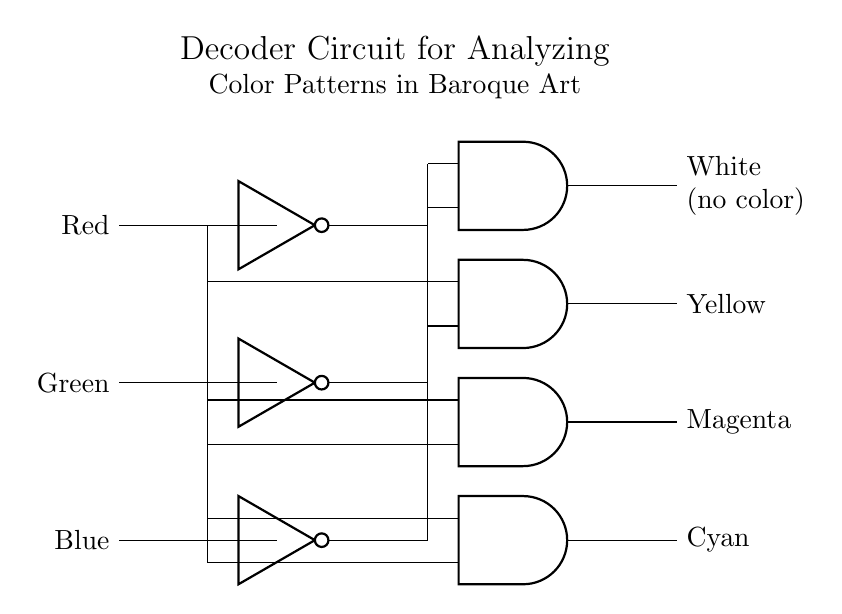What are the input colors for this decoder circuit? The circuit has three input colors labeled Red, Green, and Blue, shown at the left side of the diagram.
Answer: Red, Green, Blue What is the output color when all inputs are active? When all inputs (Red, Green, Blue) are high, the AND gates receive inputs from their respective NOT gates, leading to no signal at the output. Therefore, the output is White (no color).
Answer: White How many AND gates are present in the circuit? The circuit features four AND gates, each processing different combinations of the inputs. This is indicated by the four distinct AND gate symbols in the diagram.
Answer: Four Which output corresponds to the combination of Red and Green active, but not Blue? When Red and Green are active, but Blue is not active, the second AND gate produces Yellow as the output. This is indicated by the connections made to the second AND gate.
Answer: Yellow Describe the output color that occurs when only the Blue input is active. With only the Blue input active, the third AND gate will have both of its inputs inactive (since it requires a NOT signal from Red and Green), resulting in an output of Magenta. This is deduced from the labeling of the output from the third AND gate.
Answer: Magenta What is the function of the NOT gates in this circuit? The NOT gates invert the signals of the input colors, meaning they produce a high output when their respective input color is off. This is necessary for the AND gates to process specific color combinations accurately.
Answer: Inversion 